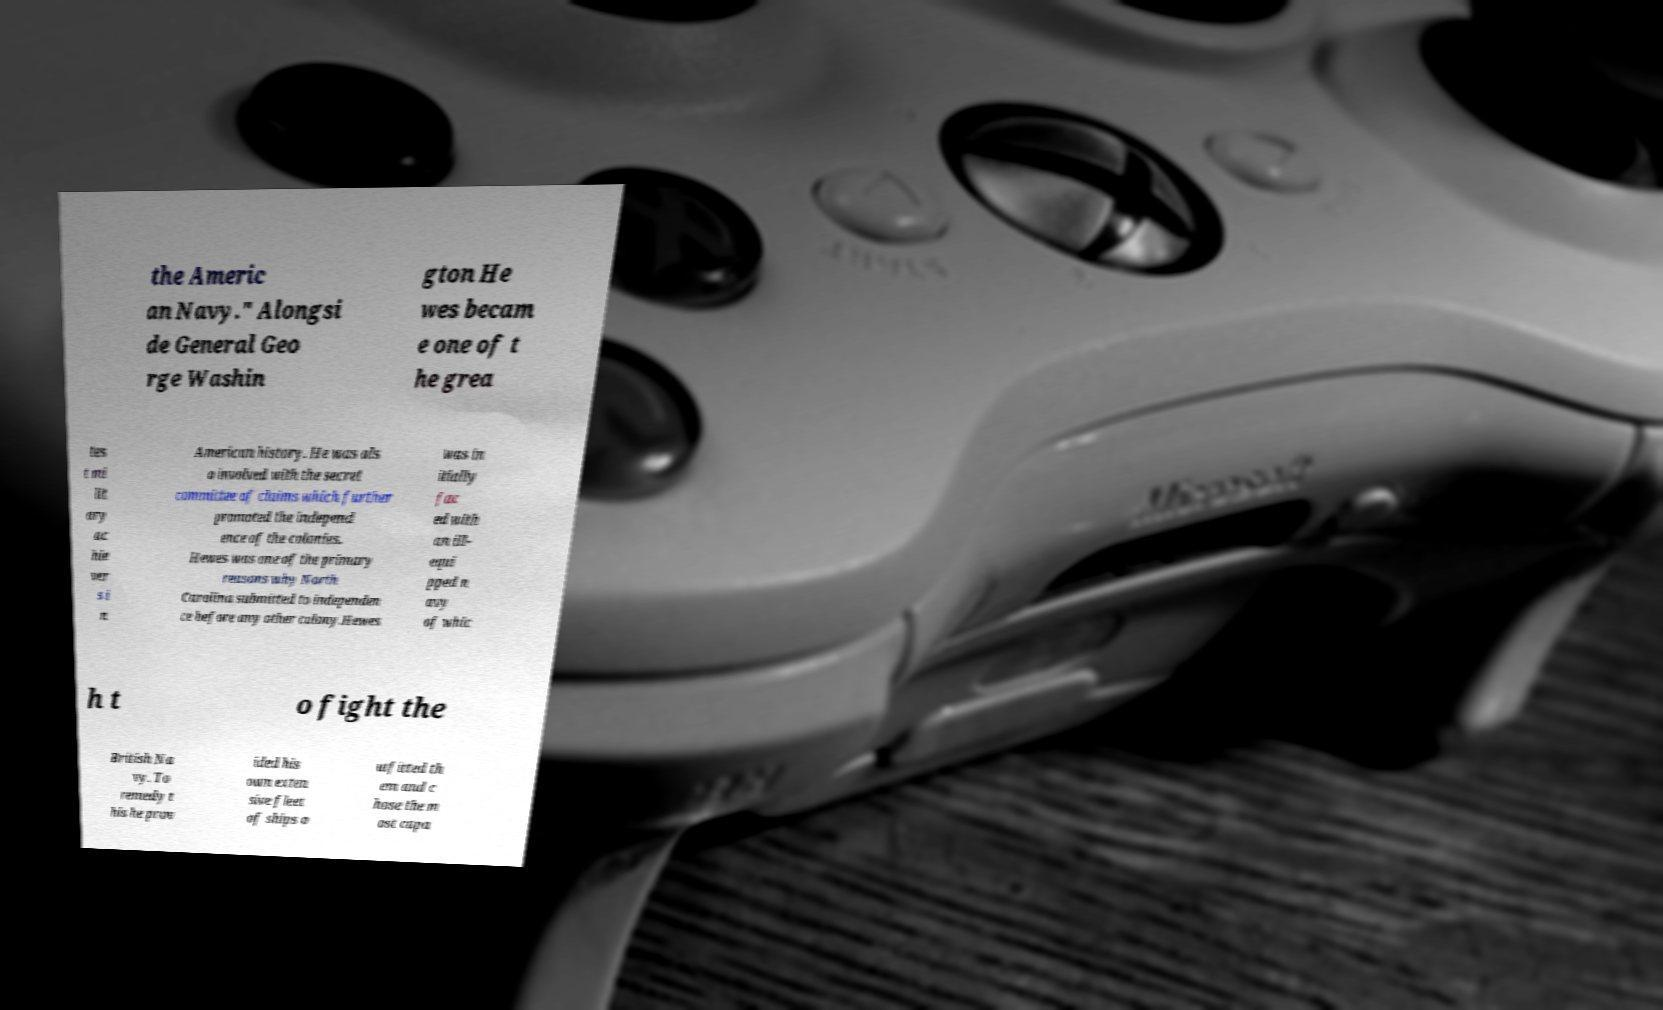Could you extract and type out the text from this image? the Americ an Navy." Alongsi de General Geo rge Washin gton He wes becam e one of t he grea tes t mi lit ary ac hie ver s i n American history. He was als o involved with the secret committee of claims which further promoted the independ ence of the colonies. Hewes was one of the primary reasons why North Carolina submitted to independen ce before any other colony.Hewes was in itially fac ed with an ill- equi pped n avy of whic h t o fight the British Na vy. To remedy t his he prov ided his own exten sive fleet of ships o utfitted th em and c hose the m ost capa 